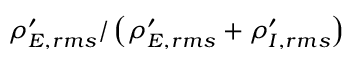<formula> <loc_0><loc_0><loc_500><loc_500>\rho _ { E , r m s } ^ { \prime } / \left ( \rho _ { E , r m s } ^ { \prime } + \rho _ { I , r m s } ^ { \prime } \right )</formula> 